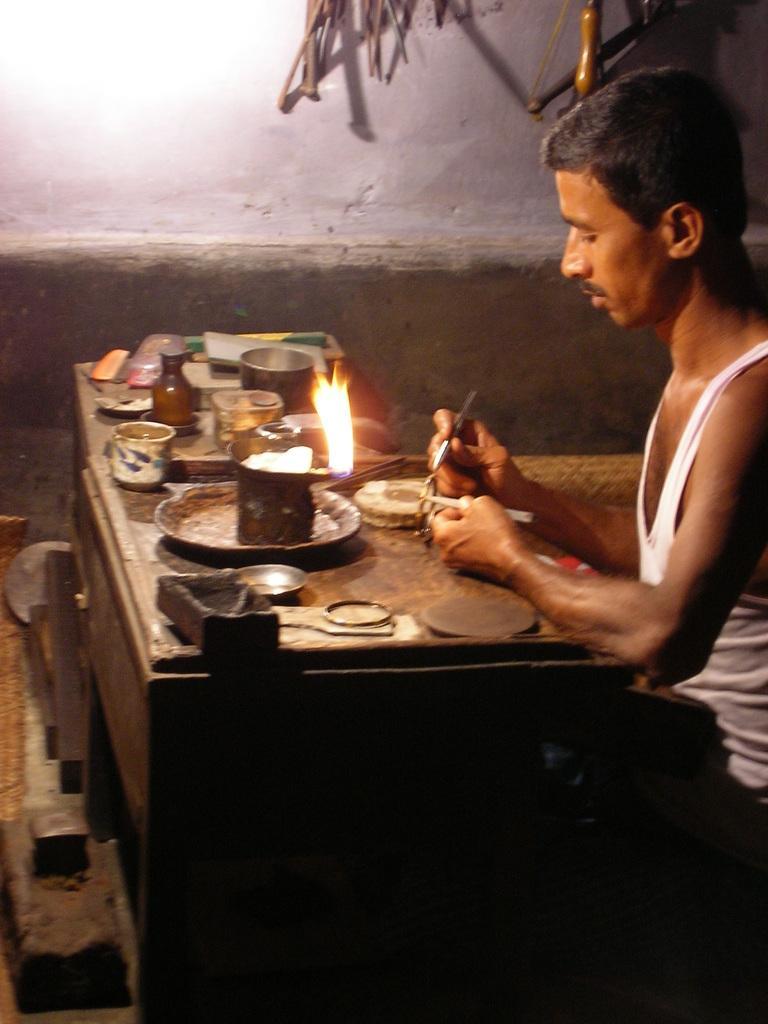Describe this image in one or two sentences. In this image we can a person sitting at the right most of the image and working. There are few objects placed on the table. 